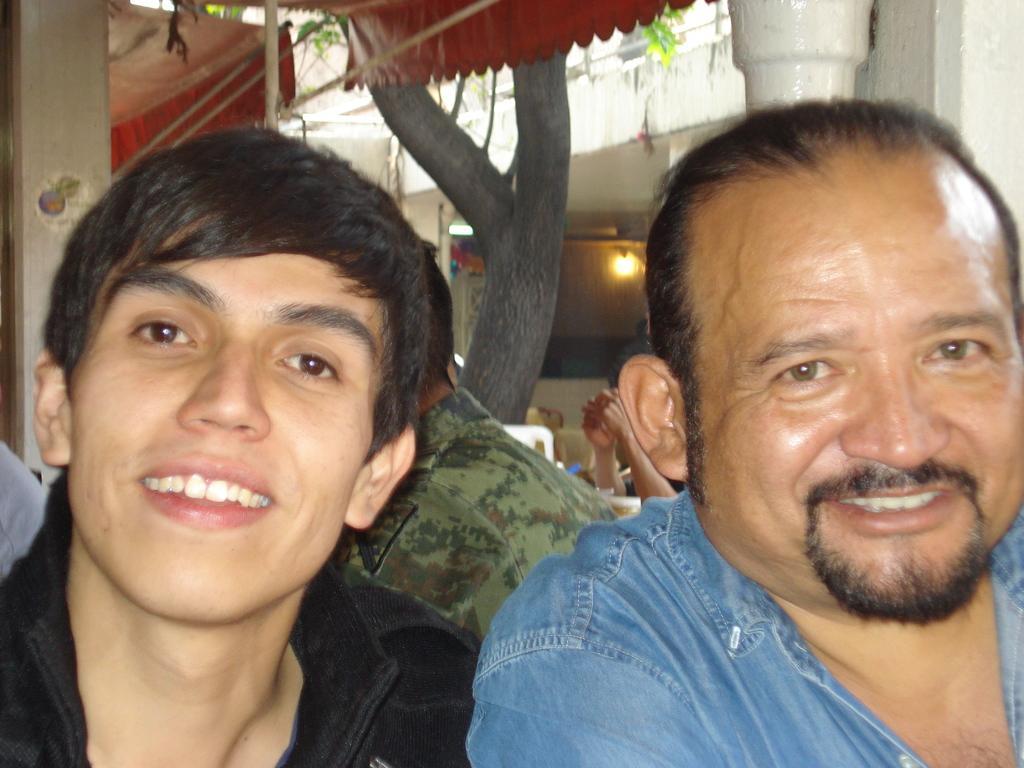In one or two sentences, can you explain what this image depicts? On the left side, there is a person in a black color shirt, smiling. On the right side, there is a person in a blue color jean shirt, smiling. In the background, there are other persons, there is a light attached to the roof of a building, there is a pipe attached to the pillar, there is a tree, there are two tents and threads. 